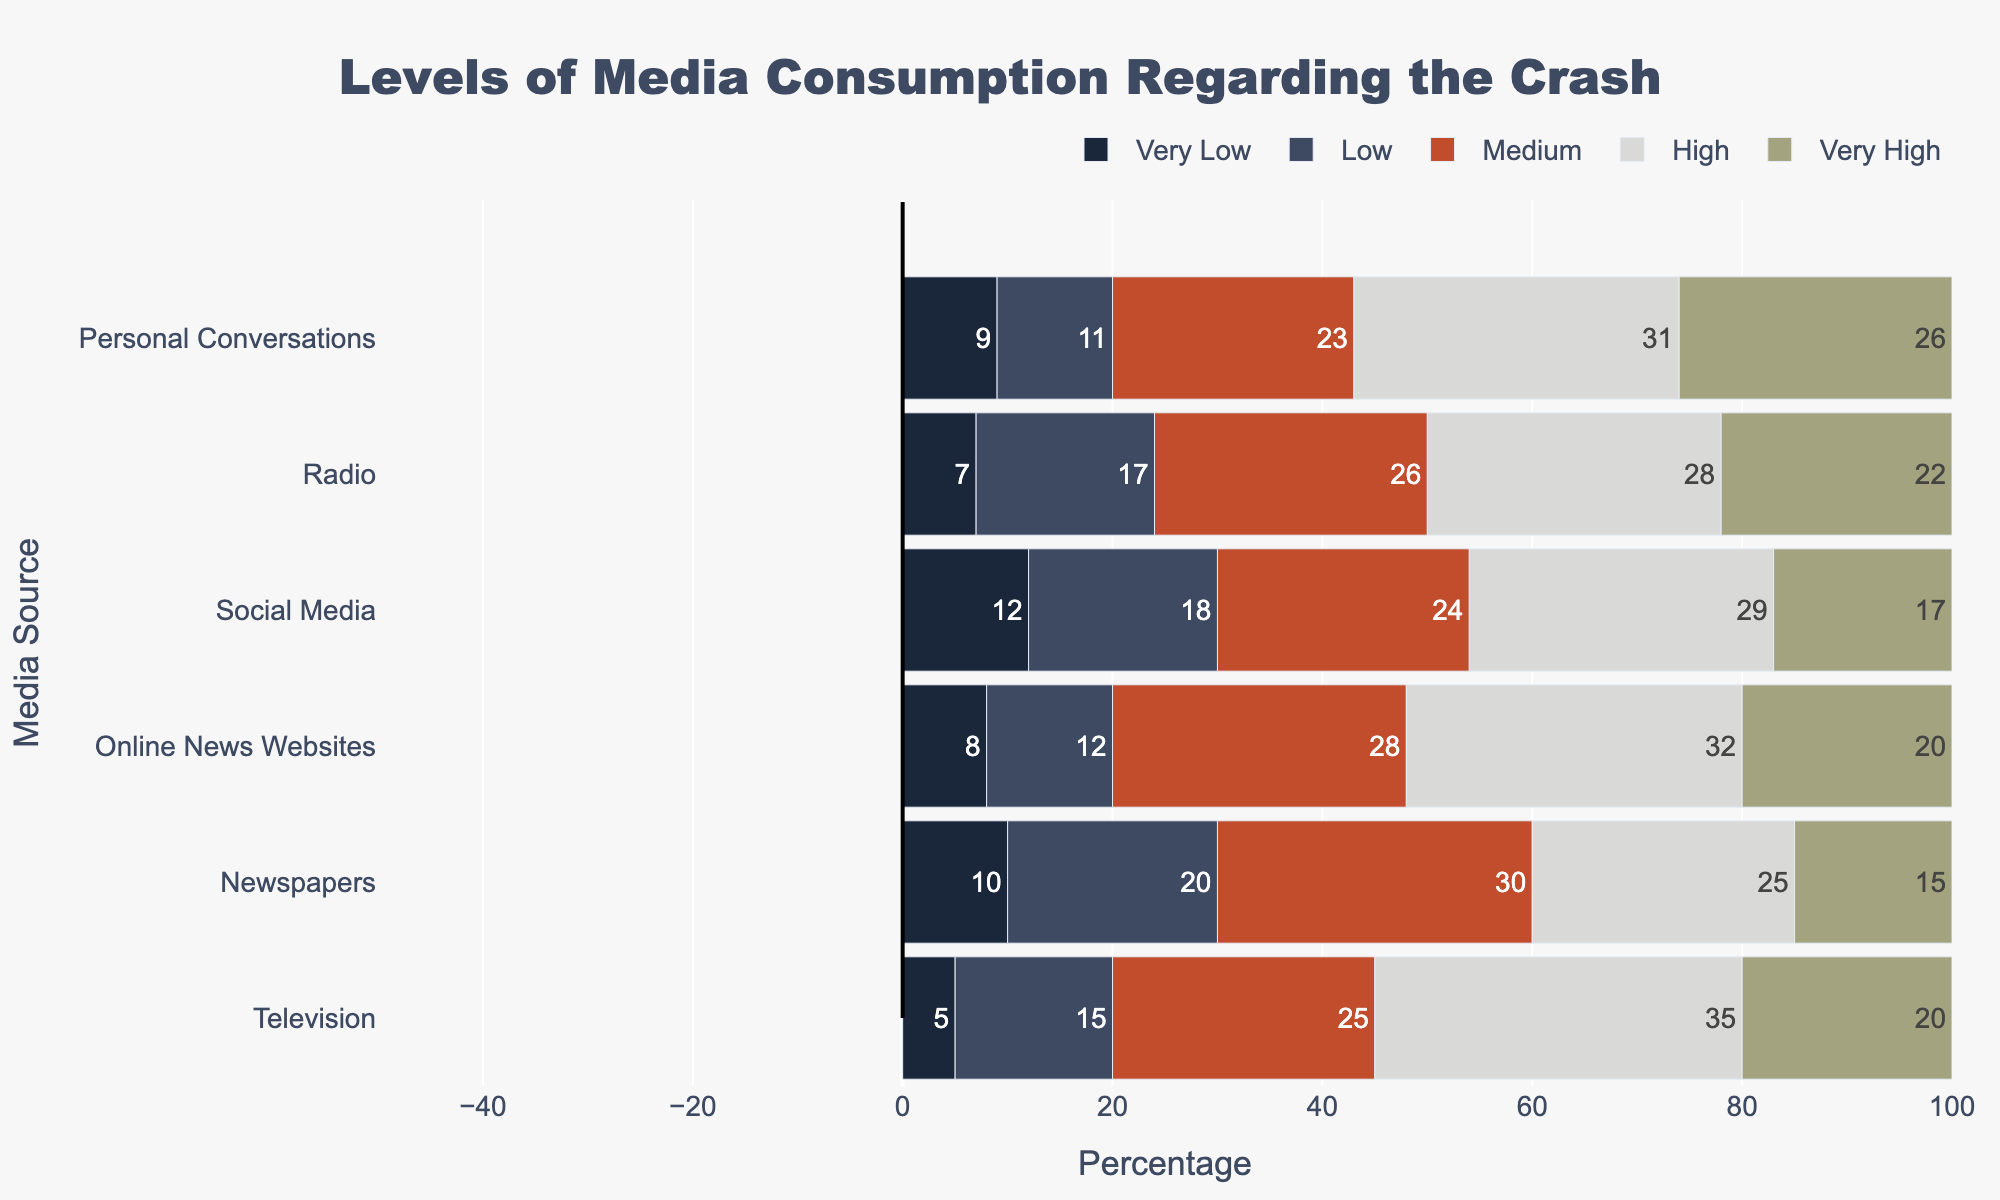Which media source has the highest percentage of "High" media consumption? By examining the height of the bars in the "High" category, the source with the longest bar in this category has the highest percentage. The source with the highest percentage in "High" is Television.
Answer: Television How does the percentage of "Low" media consumption for Social Media compare to Online News Websites? To compare, look at the lengths of the "Low" category bars for both Social Media and Online News Websites. Social Media has a slightly longer "Low" bar compared to Online News Websites.
Answer: Social Media is higher Of the listed media sources, which one has the smallest combined percentage of "Very Low" and "Low" consumption? To find this, sum the percentages of "Very Low" and "Low" for each media source. The source with the smallest total is Online News Websites (8 + 12 = 20%).
Answer: Online News Websites What is the sum of "Very High" consumption percentages across all sources? Add the "Very High" percentages from all sources: 20 (Television) + 15 (Newspapers) + 20 (Online News Websites) + 17 (Social Media) + 22 (Radio) + 26 (Personal Conversations) = 120%.
Answer: 120% What is the average percentage of "Very Low" media consumption across all sources? Sum the "Very Low" percentages and divide by the number of sources: (5 + 10 + 8 + 12 + 7 + 9) / 6 = 51 / 6 = 8.5%.
Answer: 8.5% For which media source is the "Medium" consumption percentage the highest, and what is that percentage? By looking at the "Medium" bars, Newspapers have the highest percentage in this category with 30%.
Answer: Newspapers, 30% 